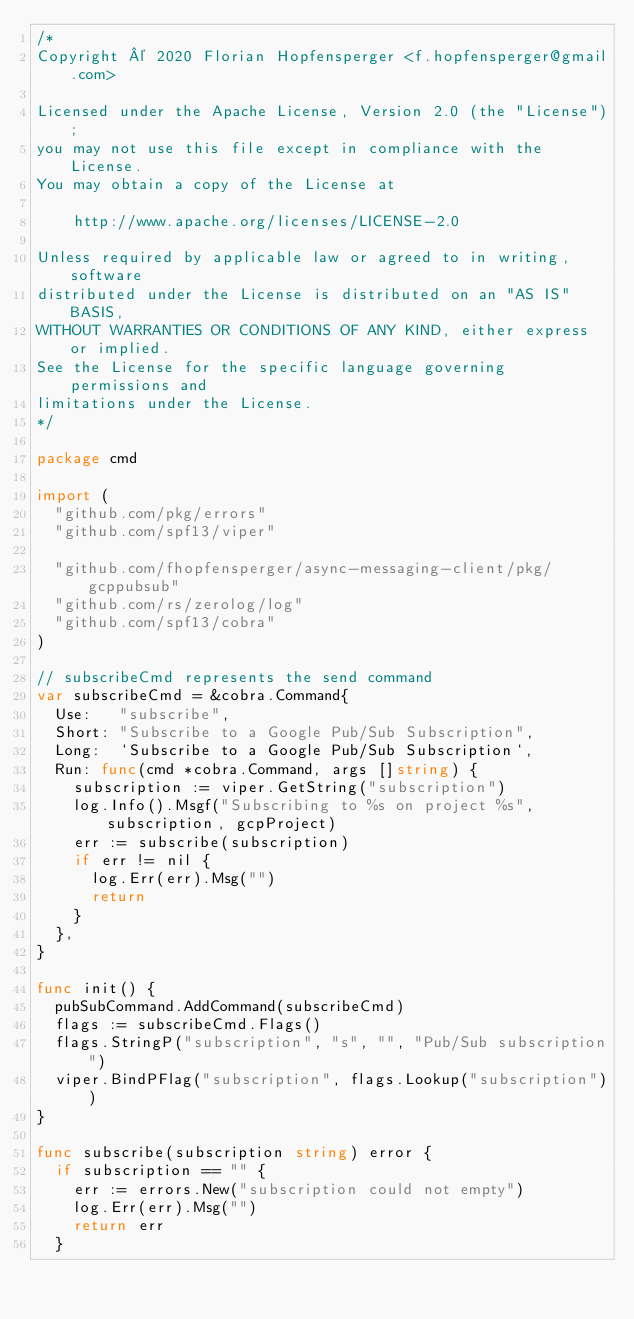Convert code to text. <code><loc_0><loc_0><loc_500><loc_500><_Go_>/*
Copyright © 2020 Florian Hopfensperger <f.hopfensperger@gmail.com>

Licensed under the Apache License, Version 2.0 (the "License");
you may not use this file except in compliance with the License.
You may obtain a copy of the License at

    http://www.apache.org/licenses/LICENSE-2.0

Unless required by applicable law or agreed to in writing, software
distributed under the License is distributed on an "AS IS" BASIS,
WITHOUT WARRANTIES OR CONDITIONS OF ANY KIND, either express or implied.
See the License for the specific language governing permissions and
limitations under the License.
*/

package cmd

import (
	"github.com/pkg/errors"
	"github.com/spf13/viper"

	"github.com/fhopfensperger/async-messaging-client/pkg/gcppubsub"
	"github.com/rs/zerolog/log"
	"github.com/spf13/cobra"
)

// subscribeCmd represents the send command
var subscribeCmd = &cobra.Command{
	Use:   "subscribe",
	Short: "Subscribe to a Google Pub/Sub Subscription",
	Long:  `Subscribe to a Google Pub/Sub Subscription`,
	Run: func(cmd *cobra.Command, args []string) {
		subscription := viper.GetString("subscription")
		log.Info().Msgf("Subscribing to %s on project %s", subscription, gcpProject)
		err := subscribe(subscription)
		if err != nil {
			log.Err(err).Msg("")
			return
		}
	},
}

func init() {
	pubSubCommand.AddCommand(subscribeCmd)
	flags := subscribeCmd.Flags()
	flags.StringP("subscription", "s", "", "Pub/Sub subscription")
	viper.BindPFlag("subscription", flags.Lookup("subscription"))
}

func subscribe(subscription string) error {
	if subscription == "" {
		err := errors.New("subscription could not empty")
		log.Err(err).Msg("")
		return err
	}</code> 